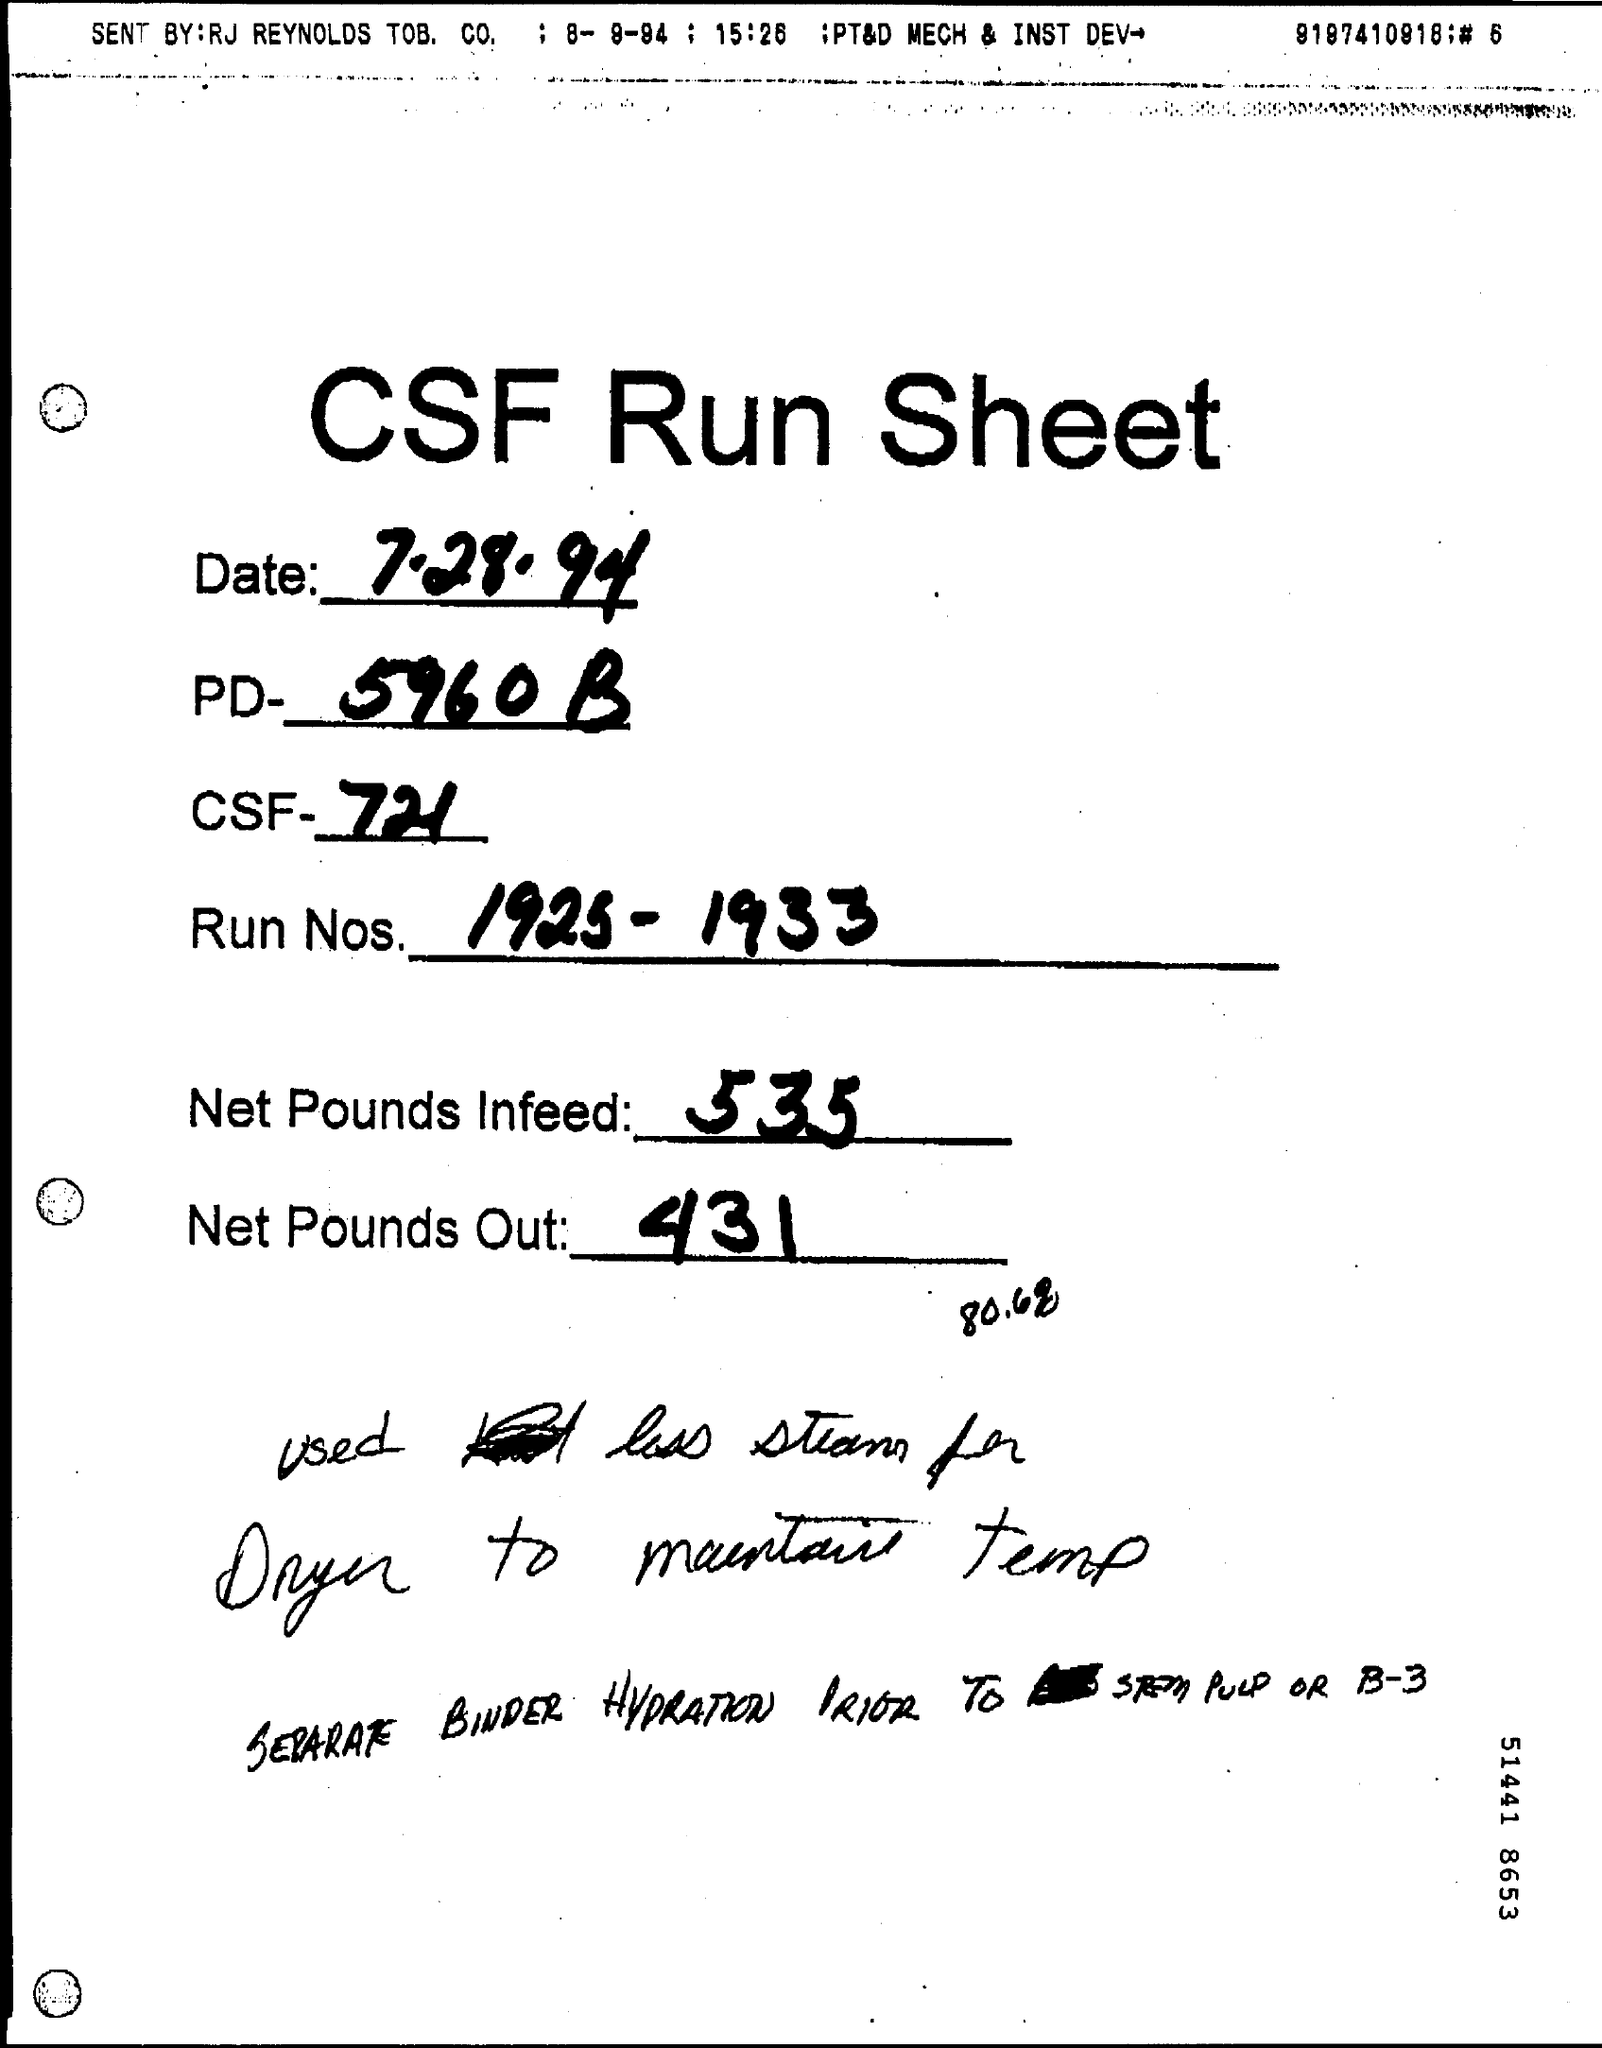Mention a couple of crucial points in this snapshot. The date mentioned in this sheet is August 7, 1994. The value entered in the Net Pounds Infeed field is 535. The PD field contains the value "5960 B.. 